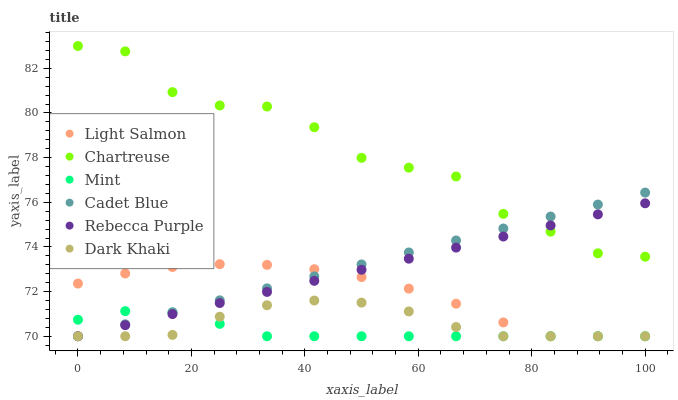Does Mint have the minimum area under the curve?
Answer yes or no. Yes. Does Chartreuse have the maximum area under the curve?
Answer yes or no. Yes. Does Cadet Blue have the minimum area under the curve?
Answer yes or no. No. Does Cadet Blue have the maximum area under the curve?
Answer yes or no. No. Is Rebecca Purple the smoothest?
Answer yes or no. Yes. Is Chartreuse the roughest?
Answer yes or no. Yes. Is Cadet Blue the smoothest?
Answer yes or no. No. Is Cadet Blue the roughest?
Answer yes or no. No. Does Light Salmon have the lowest value?
Answer yes or no. Yes. Does Chartreuse have the lowest value?
Answer yes or no. No. Does Chartreuse have the highest value?
Answer yes or no. Yes. Does Cadet Blue have the highest value?
Answer yes or no. No. Is Dark Khaki less than Chartreuse?
Answer yes or no. Yes. Is Chartreuse greater than Dark Khaki?
Answer yes or no. Yes. Does Mint intersect Light Salmon?
Answer yes or no. Yes. Is Mint less than Light Salmon?
Answer yes or no. No. Is Mint greater than Light Salmon?
Answer yes or no. No. Does Dark Khaki intersect Chartreuse?
Answer yes or no. No. 